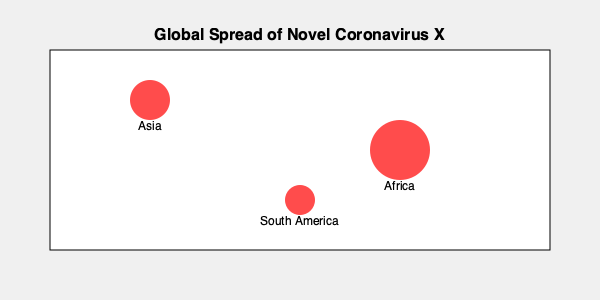Based on the world map showing hotspots of a new infectious disease called Novel Coronavirus X, which continent appears to have the largest outbreak, and what factors might contribute to its rapid spread in that region? To answer this question, let's analyze the map and consider epidemiological factors:

1. Identify the hotspots: The map shows three red circles representing outbreaks in different continents.

2. Compare the size of the hotspots: 
   - Asia: medium-sized circle
   - Africa: largest circle
   - South America: smallest circle

3. Determine the largest outbreak: Africa has the largest circle, indicating the most significant outbreak.

4. Factors contributing to rapid spread in Africa:
   a) Population density: Many African countries have densely populated urban areas, facilitating person-to-person transmission.
   b) Healthcare infrastructure: Some regions may have limited access to healthcare facilities and resources for containment.
   c) Mobility: High levels of internal and cross-border movement can accelerate disease spread.
   d) Climate: Depending on the virus's characteristics, the climate in parts of Africa might be conducive to its survival and transmission.
   e) Socioeconomic factors: Poverty and inadequate sanitation in some areas can exacerbate the spread of infectious diseases.
   f) Delayed detection and response: Limited surveillance systems might result in delayed identification and control measures.

5. Consider the role of international travel: Africa's growing connections with other continents could contribute to both the importation and exportation of cases.

6. Vaccine and treatment availability: If the disease is new, lack of specific vaccines or treatments could lead to unchecked spread, particularly in regions with limited healthcare resources.

Understanding these factors is crucial for developing effective strategies to control the outbreak and prevent further global spread.
Answer: Africa; factors include population density, healthcare infrastructure, mobility, climate, socioeconomic conditions, and potential delays in detection and response. 